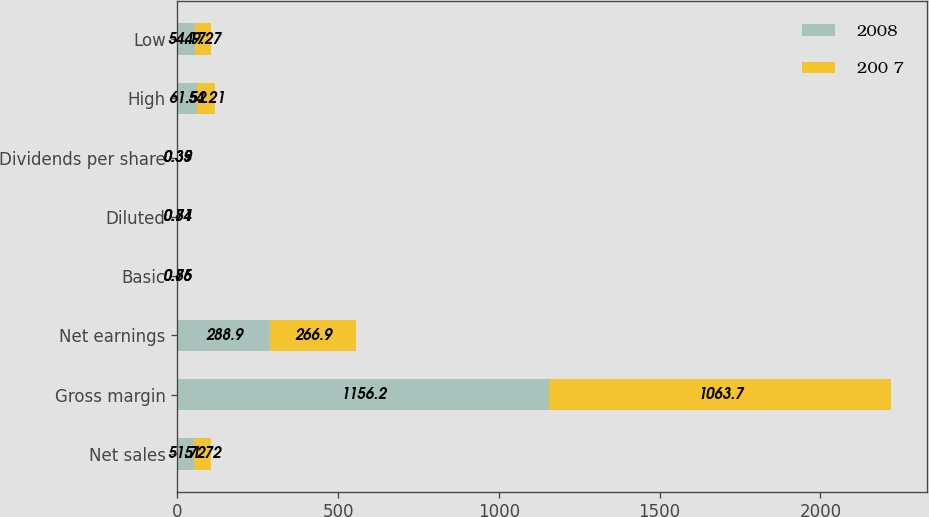Convert chart. <chart><loc_0><loc_0><loc_500><loc_500><stacked_bar_chart><ecel><fcel>Net sales<fcel>Gross margin<fcel>Net earnings<fcel>Basic<fcel>Diluted<fcel>Dividends per share<fcel>High<fcel>Low<nl><fcel>2008<fcel>51.72<fcel>1156.2<fcel>288.9<fcel>0.85<fcel>0.81<fcel>0.39<fcel>61.52<fcel>54.17<nl><fcel>200 7<fcel>51.72<fcel>1063.7<fcel>266.9<fcel>0.76<fcel>0.74<fcel>0.35<fcel>54.21<fcel>49.27<nl></chart> 